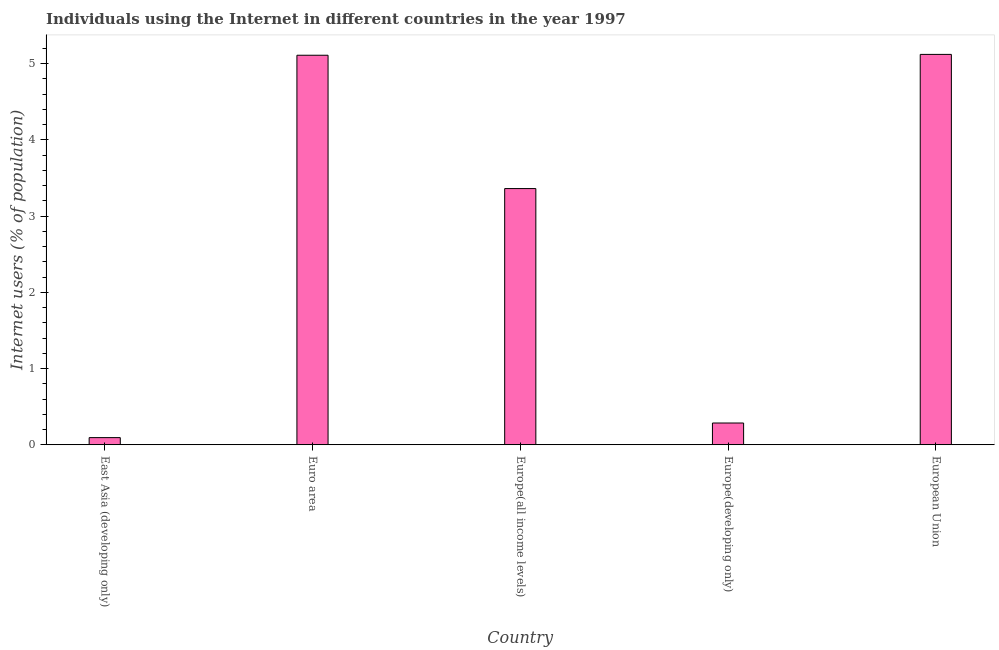Does the graph contain any zero values?
Keep it short and to the point. No. What is the title of the graph?
Keep it short and to the point. Individuals using the Internet in different countries in the year 1997. What is the label or title of the X-axis?
Provide a short and direct response. Country. What is the label or title of the Y-axis?
Offer a terse response. Internet users (% of population). What is the number of internet users in European Union?
Offer a very short reply. 5.12. Across all countries, what is the maximum number of internet users?
Make the answer very short. 5.12. Across all countries, what is the minimum number of internet users?
Keep it short and to the point. 0.09. In which country was the number of internet users minimum?
Offer a very short reply. East Asia (developing only). What is the sum of the number of internet users?
Provide a succinct answer. 13.97. What is the difference between the number of internet users in Euro area and European Union?
Your answer should be compact. -0.01. What is the average number of internet users per country?
Provide a succinct answer. 2.79. What is the median number of internet users?
Ensure brevity in your answer.  3.36. In how many countries, is the number of internet users greater than 3.8 %?
Provide a short and direct response. 2. Is the number of internet users in East Asia (developing only) less than that in Europe(developing only)?
Offer a terse response. Yes. What is the difference between the highest and the second highest number of internet users?
Ensure brevity in your answer.  0.01. What is the difference between the highest and the lowest number of internet users?
Provide a short and direct response. 5.03. How many countries are there in the graph?
Your answer should be very brief. 5. What is the difference between two consecutive major ticks on the Y-axis?
Offer a very short reply. 1. What is the Internet users (% of population) in East Asia (developing only)?
Your answer should be very brief. 0.09. What is the Internet users (% of population) of Euro area?
Provide a short and direct response. 5.11. What is the Internet users (% of population) in Europe(all income levels)?
Provide a succinct answer. 3.36. What is the Internet users (% of population) of Europe(developing only)?
Your response must be concise. 0.29. What is the Internet users (% of population) of European Union?
Your response must be concise. 5.12. What is the difference between the Internet users (% of population) in East Asia (developing only) and Euro area?
Your answer should be compact. -5.02. What is the difference between the Internet users (% of population) in East Asia (developing only) and Europe(all income levels)?
Offer a very short reply. -3.27. What is the difference between the Internet users (% of population) in East Asia (developing only) and Europe(developing only)?
Provide a succinct answer. -0.19. What is the difference between the Internet users (% of population) in East Asia (developing only) and European Union?
Ensure brevity in your answer.  -5.03. What is the difference between the Internet users (% of population) in Euro area and Europe(all income levels)?
Ensure brevity in your answer.  1.75. What is the difference between the Internet users (% of population) in Euro area and Europe(developing only)?
Offer a terse response. 4.82. What is the difference between the Internet users (% of population) in Euro area and European Union?
Offer a terse response. -0.01. What is the difference between the Internet users (% of population) in Europe(all income levels) and Europe(developing only)?
Provide a succinct answer. 3.07. What is the difference between the Internet users (% of population) in Europe(all income levels) and European Union?
Provide a short and direct response. -1.76. What is the difference between the Internet users (% of population) in Europe(developing only) and European Union?
Provide a short and direct response. -4.83. What is the ratio of the Internet users (% of population) in East Asia (developing only) to that in Euro area?
Make the answer very short. 0.02. What is the ratio of the Internet users (% of population) in East Asia (developing only) to that in Europe(all income levels)?
Provide a short and direct response. 0.03. What is the ratio of the Internet users (% of population) in East Asia (developing only) to that in Europe(developing only)?
Your answer should be compact. 0.33. What is the ratio of the Internet users (% of population) in East Asia (developing only) to that in European Union?
Give a very brief answer. 0.02. What is the ratio of the Internet users (% of population) in Euro area to that in Europe(all income levels)?
Your answer should be very brief. 1.52. What is the ratio of the Internet users (% of population) in Euro area to that in Europe(developing only)?
Your answer should be compact. 17.88. What is the ratio of the Internet users (% of population) in Euro area to that in European Union?
Make the answer very short. 1. What is the ratio of the Internet users (% of population) in Europe(all income levels) to that in Europe(developing only)?
Offer a very short reply. 11.76. What is the ratio of the Internet users (% of population) in Europe(all income levels) to that in European Union?
Provide a short and direct response. 0.66. What is the ratio of the Internet users (% of population) in Europe(developing only) to that in European Union?
Your answer should be compact. 0.06. 